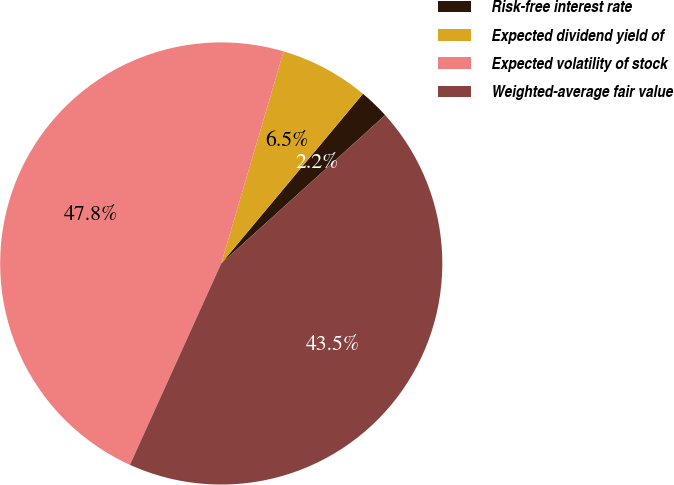Convert chart to OTSL. <chart><loc_0><loc_0><loc_500><loc_500><pie_chart><fcel>Risk-free interest rate<fcel>Expected dividend yield of<fcel>Expected volatility of stock<fcel>Weighted-average fair value<nl><fcel>2.22%<fcel>6.52%<fcel>47.78%<fcel>43.48%<nl></chart> 